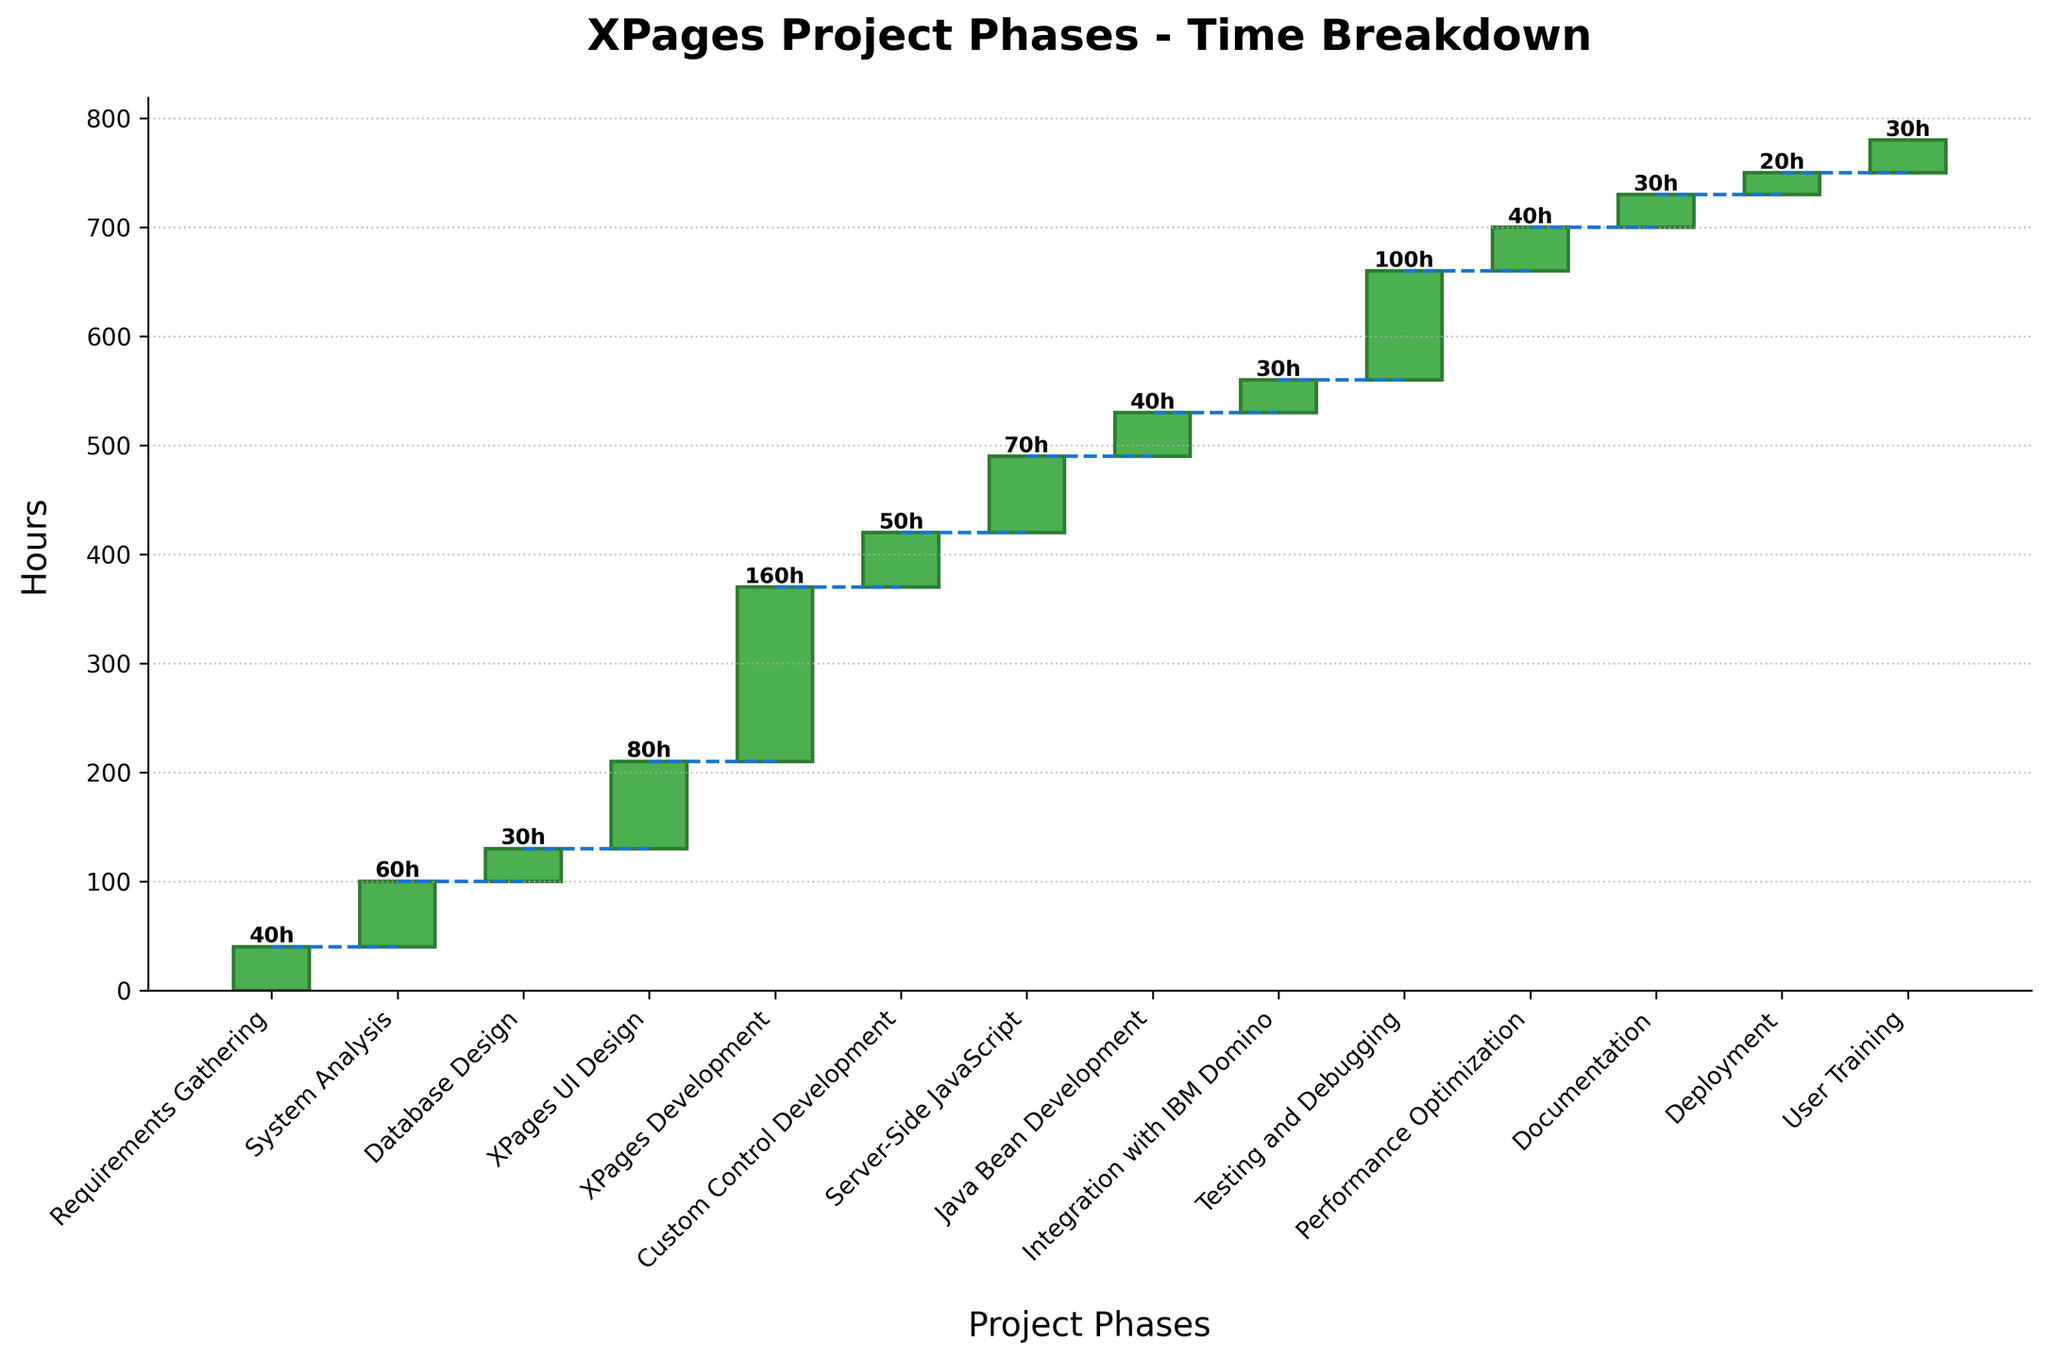What is the title of the waterfall chart? The title of the chart must be observed at the top of the figure, typically in a larger and bold font. In this case, it indicates the topic of the chart: time breakdown by different project phases.
Answer: XPages Project Phases - Time Breakdown How many hours were spent on XPages Development? Identify the XPages Development bar in the chart and look for the number displayed on or above it. This number represents the hours spent in that phase.
Answer: 160 Which phase took the least amount of time, and how many hours were spent on it? Look for the shortest bar in the chart and note its corresponding phase and hours.
Answer: Deployment, 20 What is the cumulative time spent after the Custom Control Development phase? Sum the hours of all phases from Requirements Gathering up to Custom Control Development. This involves adding 40 + 60 + 30 + 80 + 160 + 50.
Answer: 420 How much more time was spent on Testing and Debugging than on Requirements Gathering? Find the hours for both Testing and Debugging and Requirements Gathering from the chart, and calculate the difference between them. Testing and Debugging is 100 hours, and Requirements Gathering is 40 hours.
Answer: 60 Which phase immediately follows XPages Development in the order of the chart? Look at the sequence of phases displayed on the x-axis. Identify the phase that comes right after XPages Development.
Answer: Custom Control Development Summarize the total hours spent on phases related to development (XPages Development, Custom Control Development, Server-Side JavaScript, Java Bean Development). Add the hours of these development-related phases together: XPages Development (160) + Custom Control Development (50) + Server-Side JavaScript (70) + Java Bean Development (40).
Answer: 320 How many phases took 40 hours each? Identify the bars with 40 hours. Count each occurrence of a 40-hour phase.
Answer: 3 What phase took longer: Database Design or Java Bean Development? Compare the height of the bars for Database Design and Java Bean Development. Database Design is 30 hours, and Java Bean Development is 40 hours.
Answer: Java Bean Development How many hours were spent on phases before XPages Development? Calculate the sum of hours for all phases prior to XPages Development: Requirements Gathering (40) + System Analysis (60) + Database Design (30) + XPages UI Design (80).
Answer: 210 